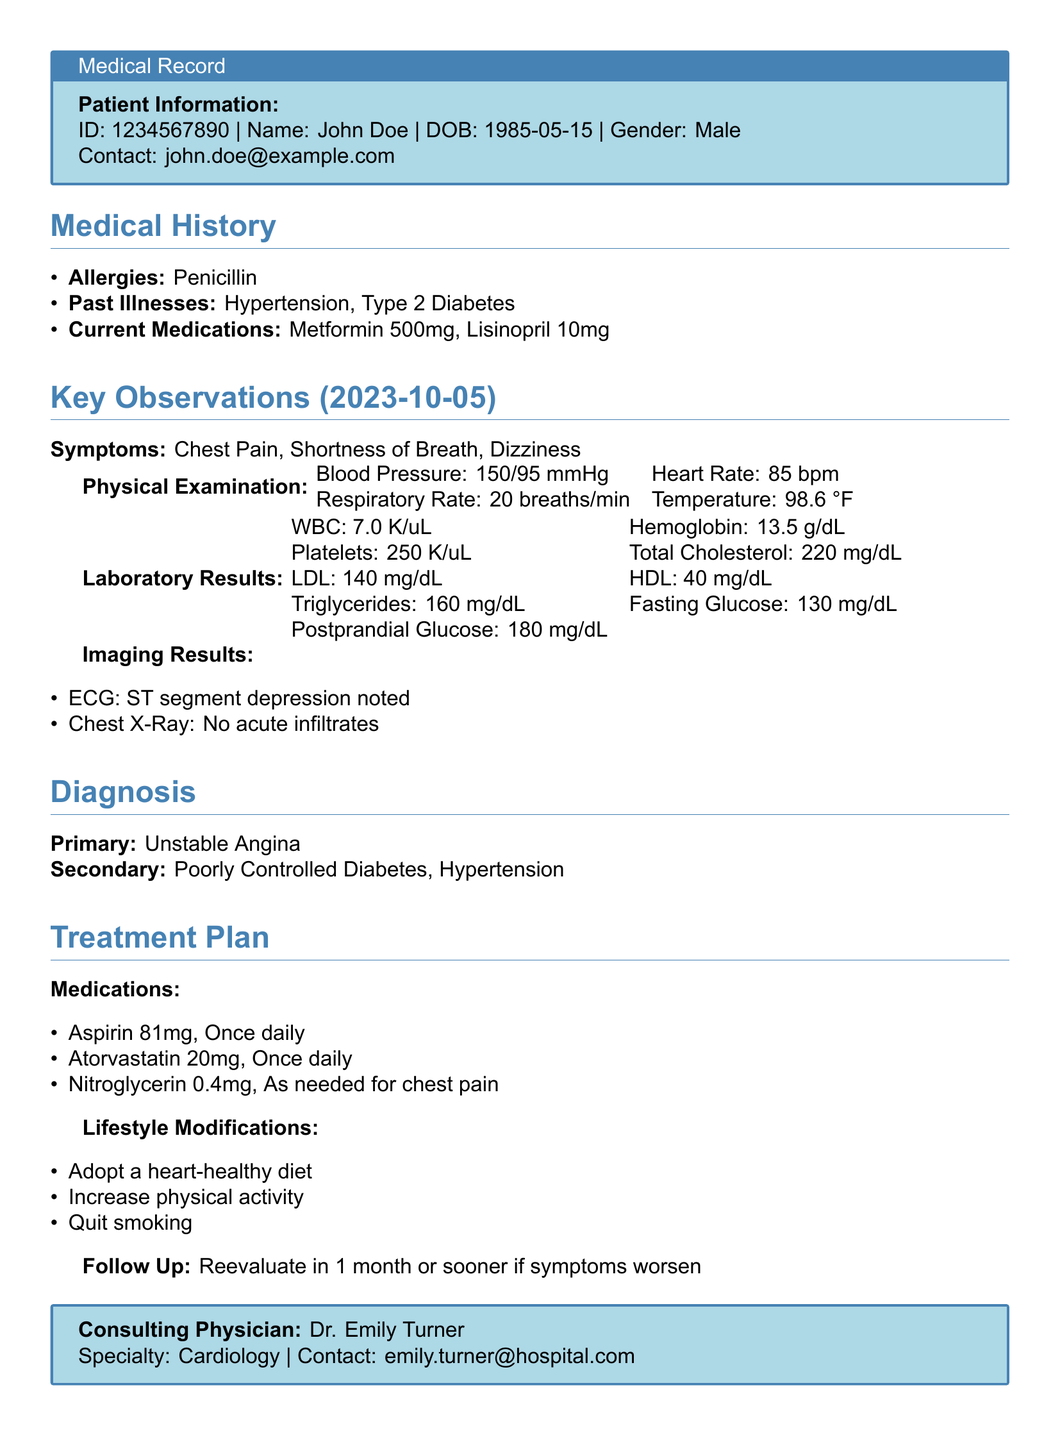What is the patient's ID? The patient's ID is provided in the patient information section of the document.
Answer: 1234567890 What are the key symptoms observed? The symptoms noted in the key observations section include specific complaints from the patient.
Answer: Chest Pain, Shortness of Breath, Dizziness What is the primary diagnosis? The primary diagnosis is explicitly stated in the diagnosis section of the document.
Answer: Unstable Angina What medication is prescribed for chest pain? The treatment plan outlines specific medications for the patient, one of which is for chest pain.
Answer: Nitroglycerin 0.4mg What lifestyle modification is suggested? The treatment plan includes recommendations for lifestyle changes to improve the patient's health.
Answer: Adopt a heart-healthy diet What is the follow-up period? The follow-up time is specified in the treatment plan regarding reevaluation of the patient's condition.
Answer: 1 month 